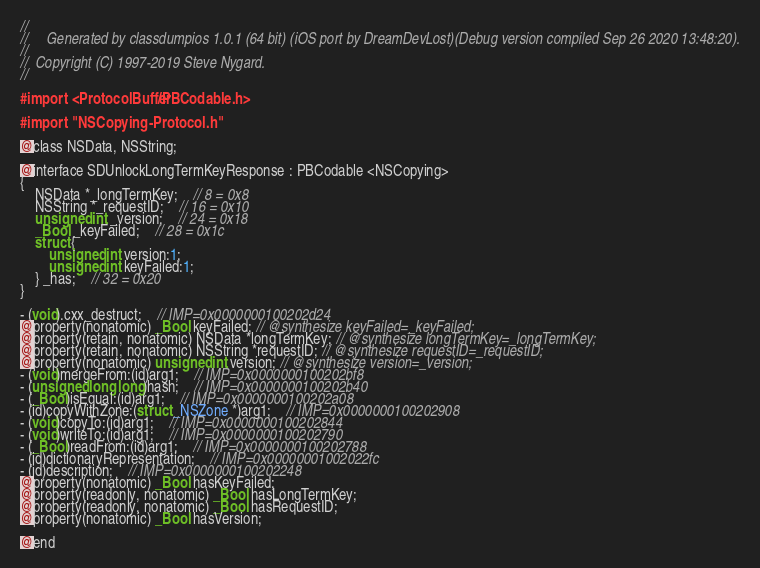Convert code to text. <code><loc_0><loc_0><loc_500><loc_500><_C_>//
//     Generated by classdumpios 1.0.1 (64 bit) (iOS port by DreamDevLost)(Debug version compiled Sep 26 2020 13:48:20).
//
//  Copyright (C) 1997-2019 Steve Nygard.
//

#import <ProtocolBuffer/PBCodable.h>

#import "NSCopying-Protocol.h"

@class NSData, NSString;

@interface SDUnlockLongTermKeyResponse : PBCodable <NSCopying>
{
    NSData *_longTermKey;	// 8 = 0x8
    NSString *_requestID;	// 16 = 0x10
    unsigned int _version;	// 24 = 0x18
    _Bool _keyFailed;	// 28 = 0x1c
    struct {
        unsigned int version:1;
        unsigned int keyFailed:1;
    } _has;	// 32 = 0x20
}

- (void).cxx_destruct;	// IMP=0x0000000100202d24
@property(nonatomic) _Bool keyFailed; // @synthesize keyFailed=_keyFailed;
@property(retain, nonatomic) NSData *longTermKey; // @synthesize longTermKey=_longTermKey;
@property(retain, nonatomic) NSString *requestID; // @synthesize requestID=_requestID;
@property(nonatomic) unsigned int version; // @synthesize version=_version;
- (void)mergeFrom:(id)arg1;	// IMP=0x0000000100202bf8
- (unsigned long long)hash;	// IMP=0x0000000100202b40
- (_Bool)isEqual:(id)arg1;	// IMP=0x0000000100202a08
- (id)copyWithZone:(struct _NSZone *)arg1;	// IMP=0x0000000100202908
- (void)copyTo:(id)arg1;	// IMP=0x0000000100202844
- (void)writeTo:(id)arg1;	// IMP=0x0000000100202790
- (_Bool)readFrom:(id)arg1;	// IMP=0x0000000100202788
- (id)dictionaryRepresentation;	// IMP=0x00000001002022fc
- (id)description;	// IMP=0x0000000100202248
@property(nonatomic) _Bool hasKeyFailed;
@property(readonly, nonatomic) _Bool hasLongTermKey;
@property(readonly, nonatomic) _Bool hasRequestID;
@property(nonatomic) _Bool hasVersion;

@end

</code> 